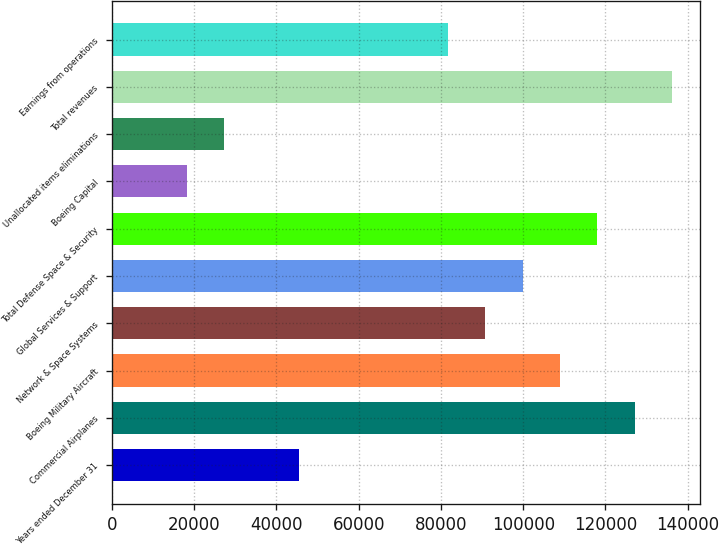<chart> <loc_0><loc_0><loc_500><loc_500><bar_chart><fcel>Years ended December 31<fcel>Commercial Airplanes<fcel>Boeing Military Aircraft<fcel>Network & Space Systems<fcel>Global Services & Support<fcel>Total Defense Space & Security<fcel>Boeing Capital<fcel>Unallocated items eliminations<fcel>Total revenues<fcel>Earnings from operations<nl><fcel>45382.5<fcel>127066<fcel>108914<fcel>90762<fcel>99837.9<fcel>117990<fcel>18154.8<fcel>27230.7<fcel>136142<fcel>81686.1<nl></chart> 